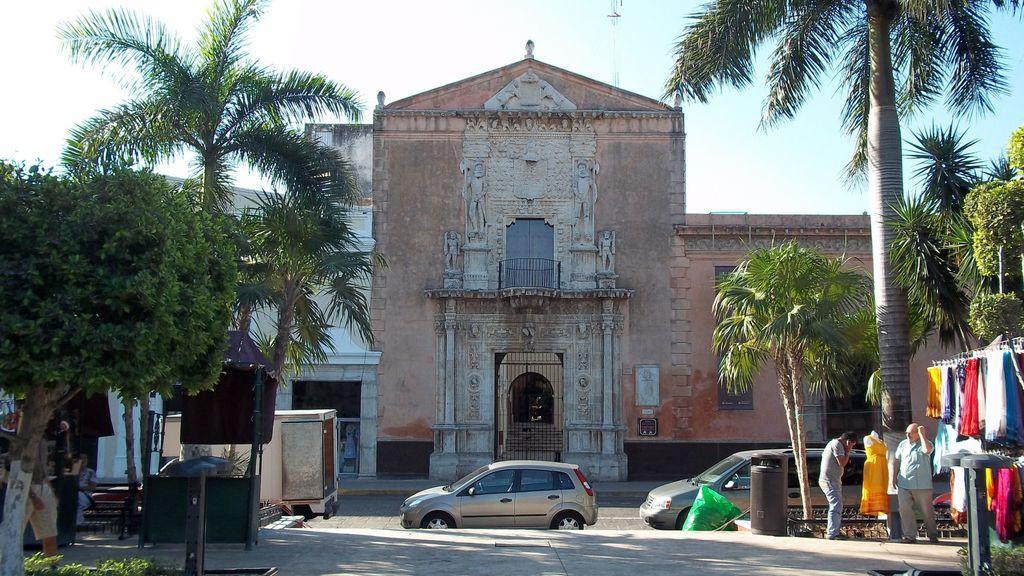In one or two sentences, can you explain what this image depicts? In the picture we can see old building on it we can see some designs with a railing gate and near it we can see three vehicles are parked and on the other side of the road we can see a path on the two sides of the path we can see some plants and trees and near it we can see two people are standing beside them we can see some clothes are hanged to the stand and in the background we can see the sky. 